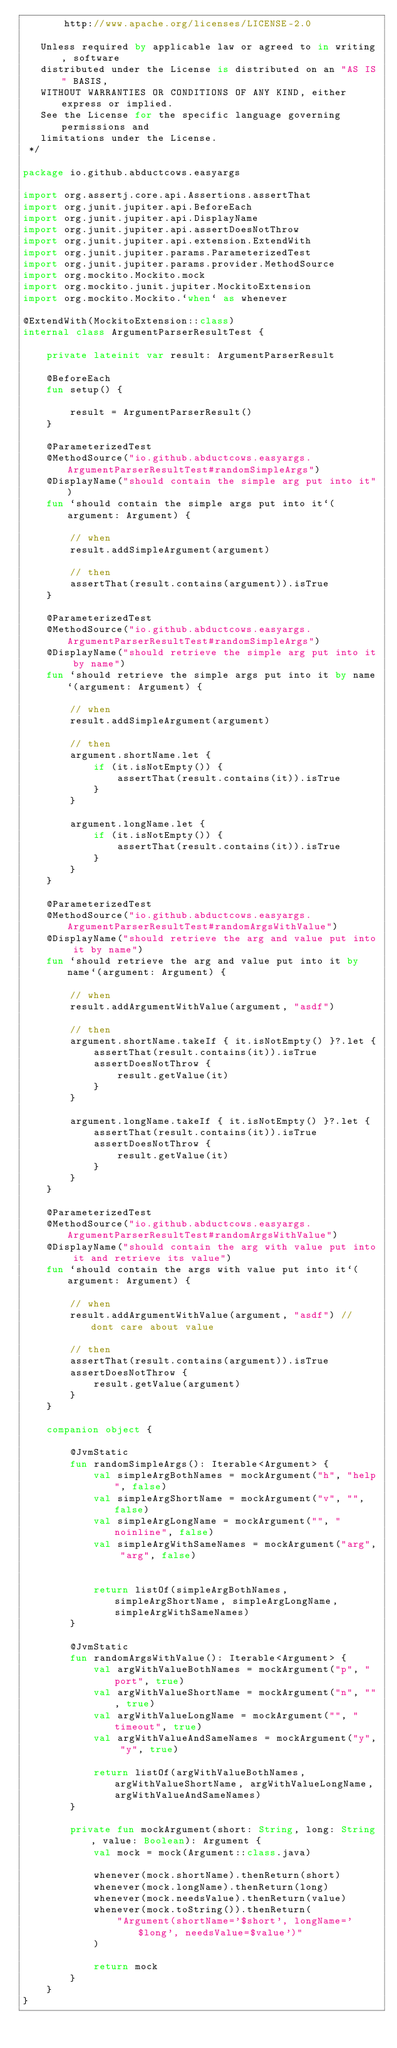<code> <loc_0><loc_0><loc_500><loc_500><_Kotlin_>       http://www.apache.org/licenses/LICENSE-2.0

   Unless required by applicable law or agreed to in writing, software
   distributed under the License is distributed on an "AS IS" BASIS,
   WITHOUT WARRANTIES OR CONDITIONS OF ANY KIND, either express or implied.
   See the License for the specific language governing permissions and
   limitations under the License.
 */

package io.github.abductcows.easyargs

import org.assertj.core.api.Assertions.assertThat
import org.junit.jupiter.api.BeforeEach
import org.junit.jupiter.api.DisplayName
import org.junit.jupiter.api.assertDoesNotThrow
import org.junit.jupiter.api.extension.ExtendWith
import org.junit.jupiter.params.ParameterizedTest
import org.junit.jupiter.params.provider.MethodSource
import org.mockito.Mockito.mock
import org.mockito.junit.jupiter.MockitoExtension
import org.mockito.Mockito.`when` as whenever

@ExtendWith(MockitoExtension::class)
internal class ArgumentParserResultTest {

    private lateinit var result: ArgumentParserResult

    @BeforeEach
    fun setup() {

        result = ArgumentParserResult()
    }

    @ParameterizedTest
    @MethodSource("io.github.abductcows.easyargs.ArgumentParserResultTest#randomSimpleArgs")
    @DisplayName("should contain the simple arg put into it")
    fun `should contain the simple args put into it`(argument: Argument) {

        // when
        result.addSimpleArgument(argument)

        // then
        assertThat(result.contains(argument)).isTrue
    }

    @ParameterizedTest
    @MethodSource("io.github.abductcows.easyargs.ArgumentParserResultTest#randomSimpleArgs")
    @DisplayName("should retrieve the simple arg put into it by name")
    fun `should retrieve the simple args put into it by name`(argument: Argument) {

        // when
        result.addSimpleArgument(argument)

        // then
        argument.shortName.let {
            if (it.isNotEmpty()) {
                assertThat(result.contains(it)).isTrue
            }
        }

        argument.longName.let {
            if (it.isNotEmpty()) {
                assertThat(result.contains(it)).isTrue
            }
        }
    }

    @ParameterizedTest
    @MethodSource("io.github.abductcows.easyargs.ArgumentParserResultTest#randomArgsWithValue")
    @DisplayName("should retrieve the arg and value put into it by name")
    fun `should retrieve the arg and value put into it by name`(argument: Argument) {

        // when
        result.addArgumentWithValue(argument, "asdf")

        // then
        argument.shortName.takeIf { it.isNotEmpty() }?.let {
            assertThat(result.contains(it)).isTrue
            assertDoesNotThrow {
                result.getValue(it)
            }
        }

        argument.longName.takeIf { it.isNotEmpty() }?.let {
            assertThat(result.contains(it)).isTrue
            assertDoesNotThrow {
                result.getValue(it)
            }
        }
    }

    @ParameterizedTest
    @MethodSource("io.github.abductcows.easyargs.ArgumentParserResultTest#randomArgsWithValue")
    @DisplayName("should contain the arg with value put into it and retrieve its value")
    fun `should contain the args with value put into it`(argument: Argument) {

        // when
        result.addArgumentWithValue(argument, "asdf") // dont care about value

        // then
        assertThat(result.contains(argument)).isTrue
        assertDoesNotThrow {
            result.getValue(argument)
        }
    }

    companion object {

        @JvmStatic
        fun randomSimpleArgs(): Iterable<Argument> {
            val simpleArgBothNames = mockArgument("h", "help", false)
            val simpleArgShortName = mockArgument("v", "", false)
            val simpleArgLongName = mockArgument("", "noinline", false)
            val simpleArgWithSameNames = mockArgument("arg", "arg", false)


            return listOf(simpleArgBothNames, simpleArgShortName, simpleArgLongName, simpleArgWithSameNames)
        }

        @JvmStatic
        fun randomArgsWithValue(): Iterable<Argument> {
            val argWithValueBothNames = mockArgument("p", "port", true)
            val argWithValueShortName = mockArgument("n", "", true)
            val argWithValueLongName = mockArgument("", "timeout", true)
            val argWithValueAndSameNames = mockArgument("y", "y", true)

            return listOf(argWithValueBothNames, argWithValueShortName, argWithValueLongName, argWithValueAndSameNames)
        }

        private fun mockArgument(short: String, long: String, value: Boolean): Argument {
            val mock = mock(Argument::class.java)

            whenever(mock.shortName).thenReturn(short)
            whenever(mock.longName).thenReturn(long)
            whenever(mock.needsValue).thenReturn(value)
            whenever(mock.toString()).thenReturn(
                "Argument(shortName='$short', longName='$long', needsValue=$value')"
            )

            return mock
        }
    }
}
</code> 